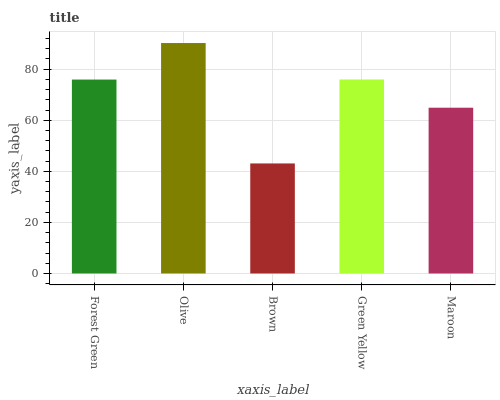Is Brown the minimum?
Answer yes or no. Yes. Is Olive the maximum?
Answer yes or no. Yes. Is Olive the minimum?
Answer yes or no. No. Is Brown the maximum?
Answer yes or no. No. Is Olive greater than Brown?
Answer yes or no. Yes. Is Brown less than Olive?
Answer yes or no. Yes. Is Brown greater than Olive?
Answer yes or no. No. Is Olive less than Brown?
Answer yes or no. No. Is Forest Green the high median?
Answer yes or no. Yes. Is Forest Green the low median?
Answer yes or no. Yes. Is Maroon the high median?
Answer yes or no. No. Is Maroon the low median?
Answer yes or no. No. 